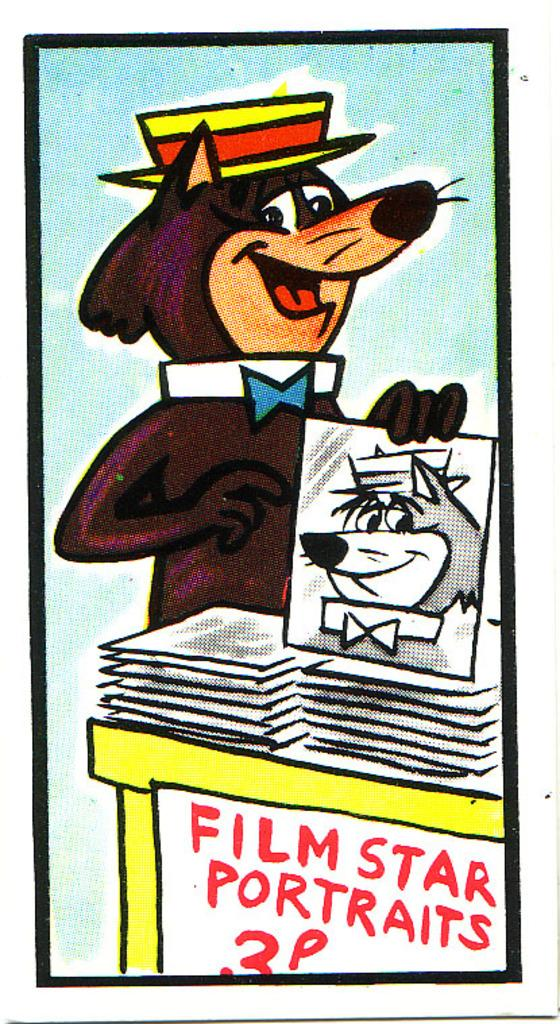<image>
Share a concise interpretation of the image provided. A bear cartoon is passing out a stack of Film Star Portraits for 3p. 